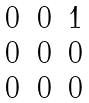<formula> <loc_0><loc_0><loc_500><loc_500>\begin{matrix} 0 & 0 & 1 \\ 0 & 0 & 0 \\ 0 & 0 & 0 \\ \end{matrix}</formula> 